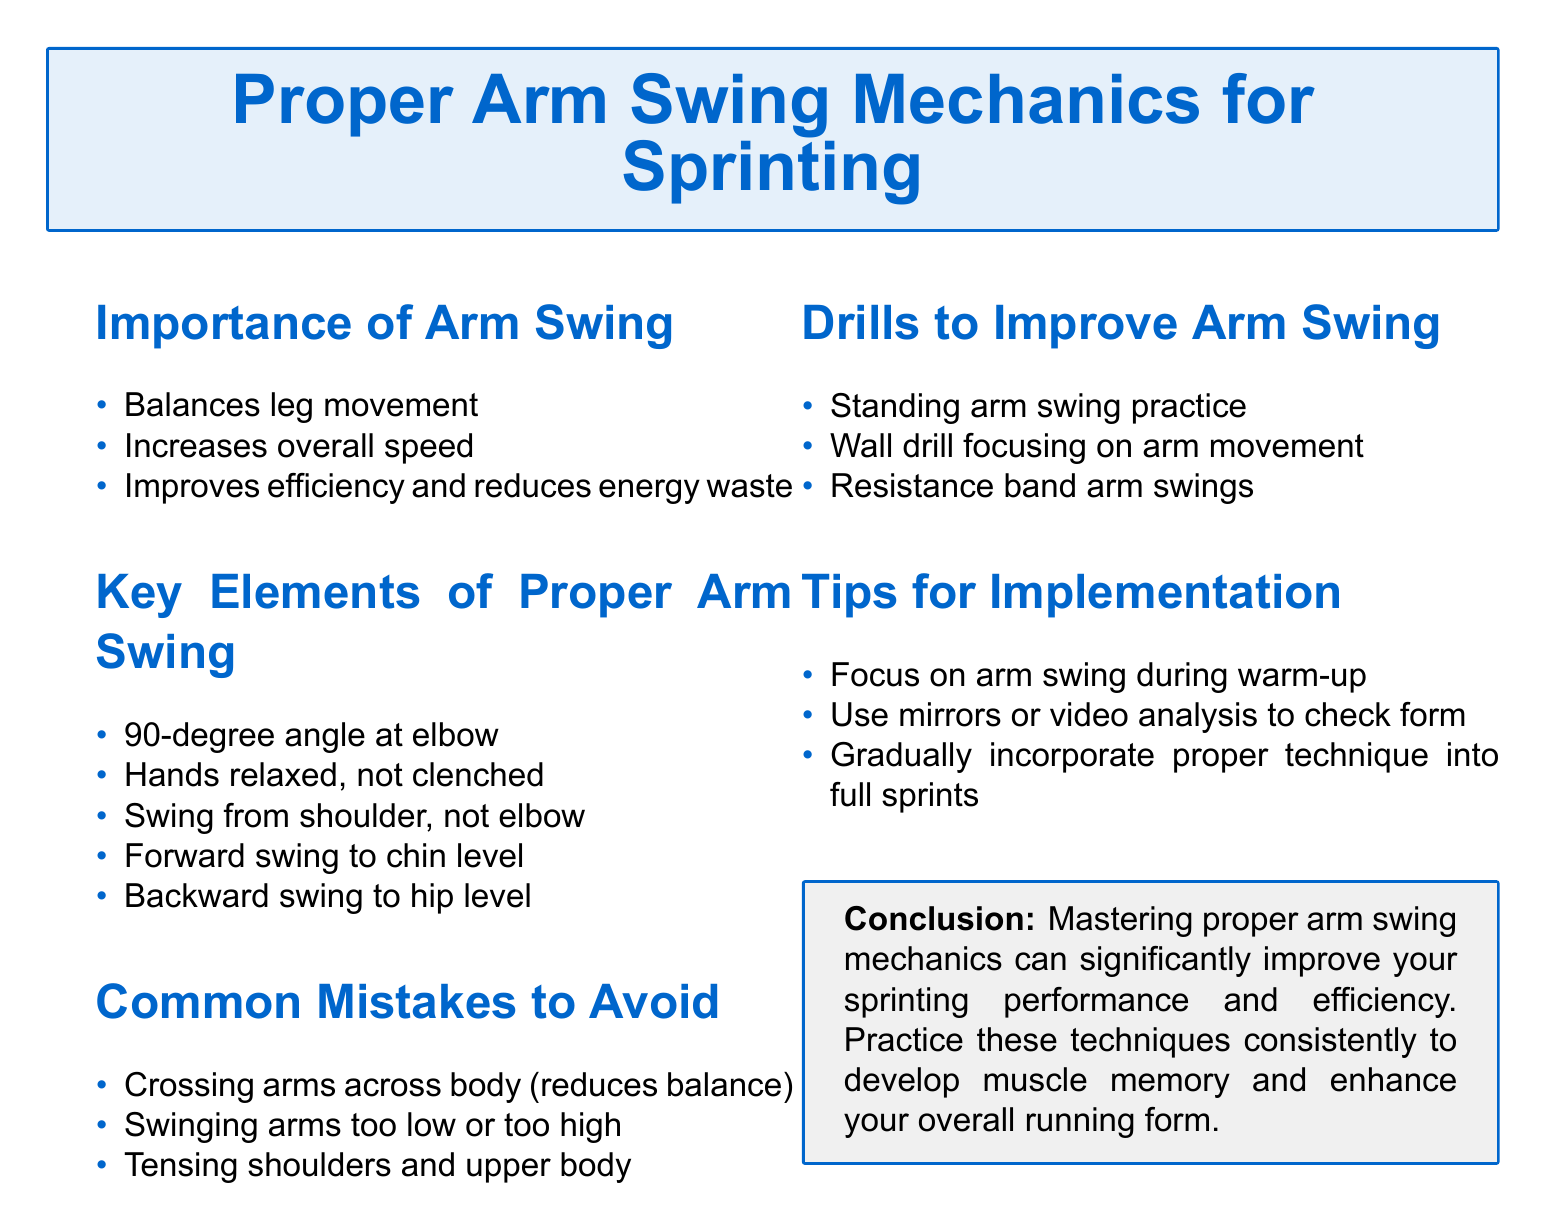What are the three benefits of arm swing? The benefits of arm swing include balancing leg movement, increasing overall speed, and improving efficiency and reducing energy waste.
Answer: Balances leg movement, increases overall speed, improves efficiency and reduces energy waste What angle should the elbow be at during proper arm swing? The document specifies that the angle at the elbow should be 90 degrees during proper arm swing.
Answer: 90-degree angle at elbow What is a common mistake regarding arm position? One common mistake is crossing arms across the body, which reduces balance.
Answer: Crossing arms across body Name a drill to improve arm swing. The document lists drills such as standing arm swing practice, wall drill, and resistance band arm swings.
Answer: Standing arm swing practice What should you focus on during warm-up? The document advises focusing on arm swing during warm-up.
Answer: Arm swing In what level should the backward swing go? The document states that the backward swing should go to hip level.
Answer: Hip level Which part of the body should the swing originate from? The arm swing should originate from the shoulder, not the elbow.
Answer: Shoulder What tool can be used for form analysis? The document suggests using mirrors or video analysis to check form.
Answer: Mirrors or video analysis What is the conclusion about mastering arm swing mechanics? The conclusion highlights that mastering proper arm swing mechanics can significantly improve sprinting performance and efficiency.
Answer: Improve your sprinting performance and efficiency 